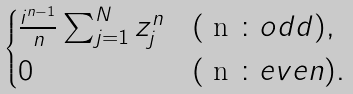Convert formula to latex. <formula><loc_0><loc_0><loc_500><loc_500>\begin{cases} \frac { i ^ { n - 1 } } { n } \sum _ { j = 1 } ^ { N } z _ { j } ^ { n } & ( $ n $ \colon o d d ) , \\ 0 & ( $ n $ \colon e v e n ) . \\ \end{cases}</formula> 